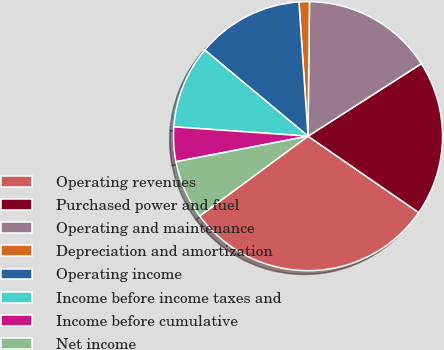Convert chart. <chart><loc_0><loc_0><loc_500><loc_500><pie_chart><fcel>Operating revenues<fcel>Purchased power and fuel<fcel>Operating and maintenance<fcel>Depreciation and amortization<fcel>Operating income<fcel>Income before income taxes and<fcel>Income before cumulative<fcel>Net income<nl><fcel>30.28%<fcel>18.67%<fcel>15.77%<fcel>1.25%<fcel>12.86%<fcel>9.96%<fcel>4.15%<fcel>7.06%<nl></chart> 